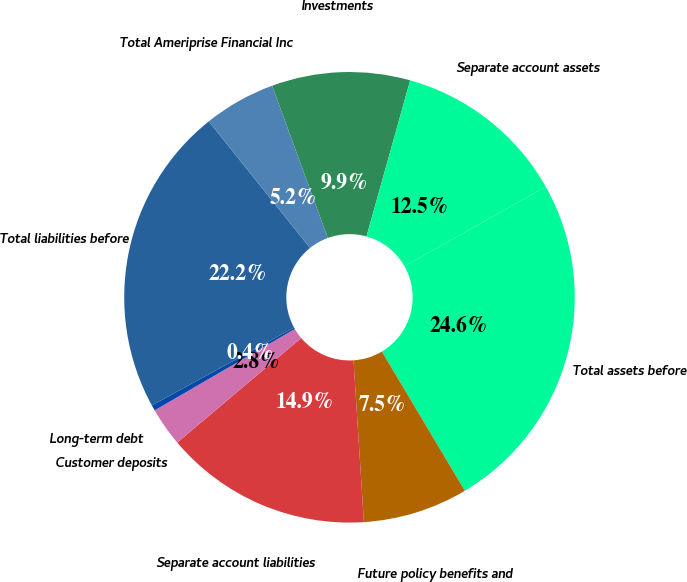Convert chart to OTSL. <chart><loc_0><loc_0><loc_500><loc_500><pie_chart><fcel>Investments<fcel>Separate account assets<fcel>Total assets before<fcel>Future policy benefits and<fcel>Separate account liabilities<fcel>Customer deposits<fcel>Long-term debt<fcel>Total liabilities before<fcel>Total Ameriprise Financial Inc<nl><fcel>9.92%<fcel>12.49%<fcel>24.61%<fcel>7.54%<fcel>14.87%<fcel>2.78%<fcel>0.4%<fcel>22.23%<fcel>5.16%<nl></chart> 